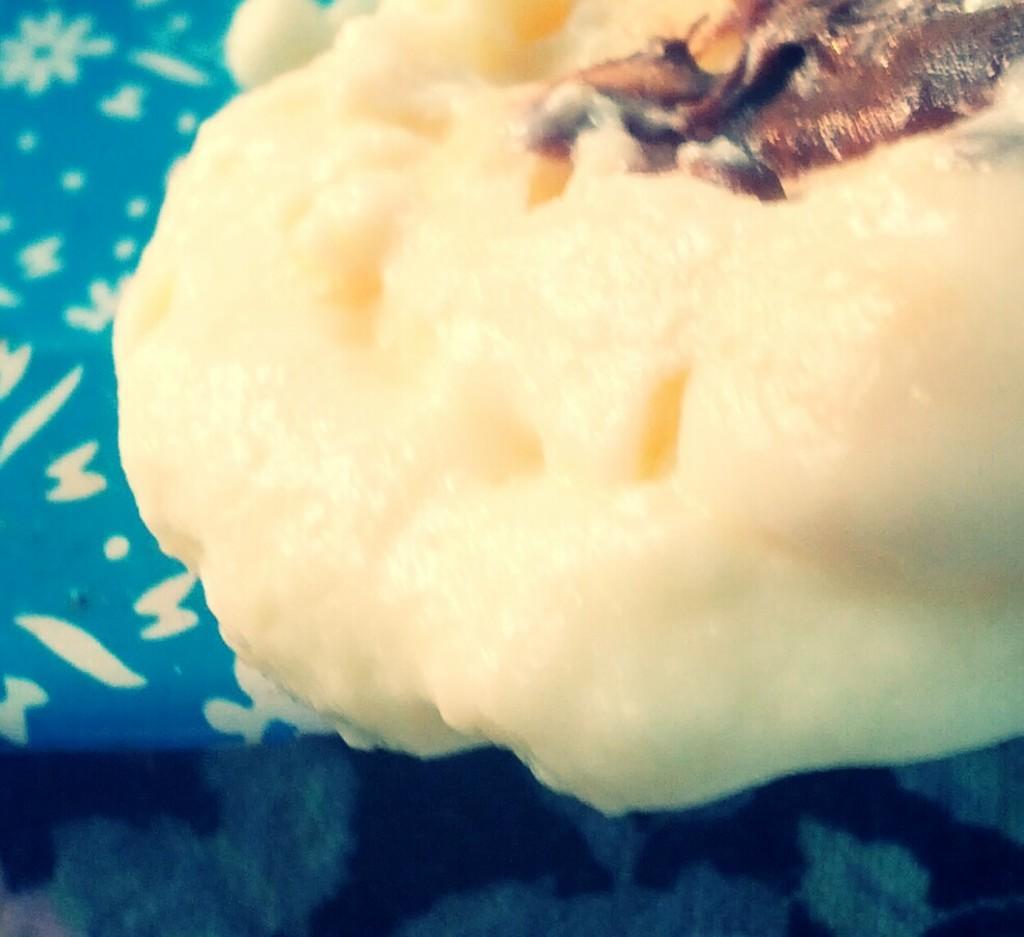What type of food can be seen in the image? The food in the image has white and brown colors. Can you describe the colors of the food? The food has white and brown colors. What is located on the left side of the image? There is a blue object on the left side of the image. What type of country is depicted in the image? There is no country depicted in the image; it features food and a blue object. Can you see any rays in the image? There are no rays present in the image. 